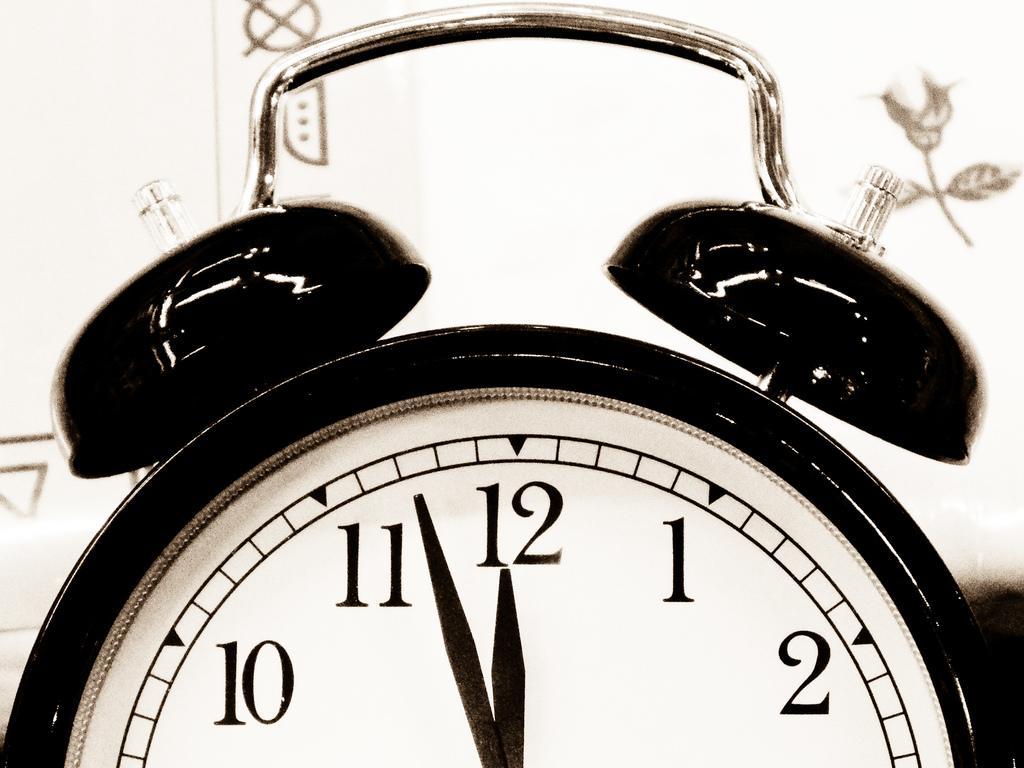Provide a one-sentence caption for the provided image. An old fashion alarm clock with a white face and black body reads 3 minutes to 12. 